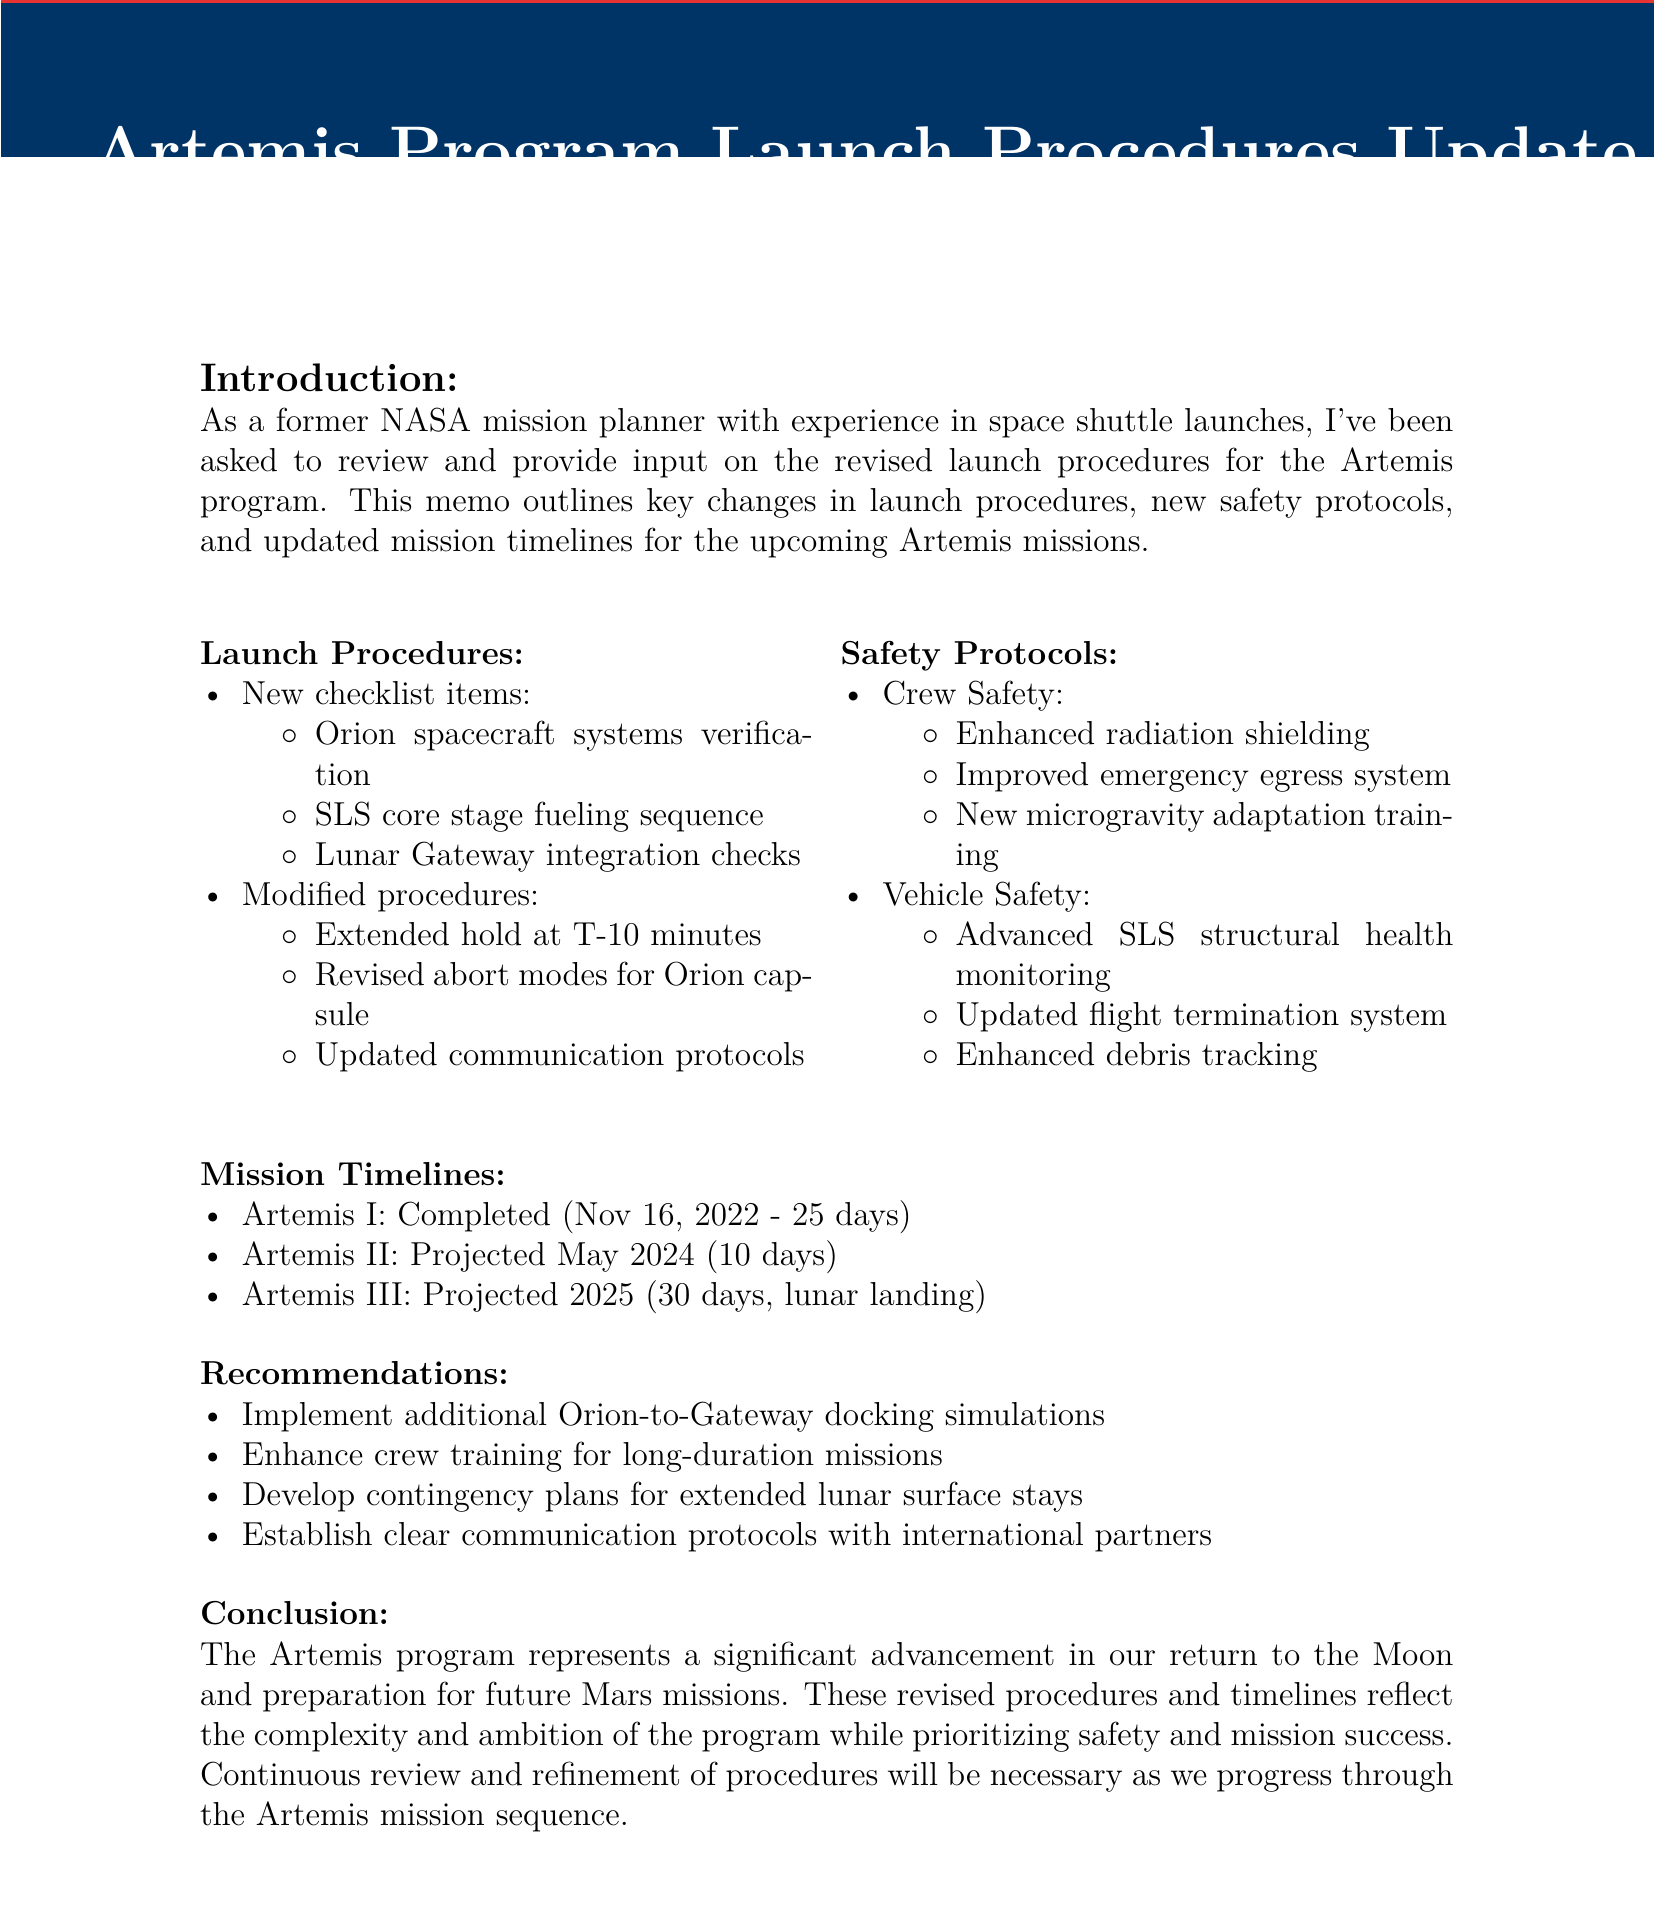What is the memo title? The memo title is provided at the beginning of the document as the focus of the memo.
Answer: Artemis Program Launch Procedures Update What is the projected launch date for Artemis II? The projected launch date for Artemis II is mentioned in the mission timelines section of the document.
Answer: May 2024 Which enhanced safety feature is included for crew safety? Crew safety enhancements are listed in the safety protocols section, specifying improvements for the Orion capsule.
Answer: Enhanced radiation shielding How long did Artemis I last? The duration of Artemis I is specified within the mission timelines in the document.
Answer: 25 days, 10 hours, 54 minutes What is one of the new checklist items for launch procedures? New checklist items are provided under the launch procedures section of the document.
Answer: Orion spacecraft systems verification What recommendation is made regarding crew training? Recommendations are listed in a specific section focusing on improving readiness for missions.
Answer: Enhance crew training for long-duration missions beyond low Earth orbit Which program's increased automation is compared to the shuttle? The comparisons section discusses the advancements achieved in the current program relative to earlier missions.
Answer: Artemis What does the revised abort mode apply to? The modified procedures list outlines specific changes made to enhance safety during operations.
Answer: Orion capsule 